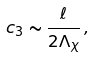<formula> <loc_0><loc_0><loc_500><loc_500>c _ { 3 } \sim \frac { \ell } { 2 \Lambda _ { \chi } } \, ,</formula> 